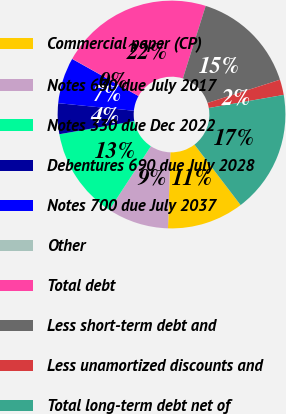<chart> <loc_0><loc_0><loc_500><loc_500><pie_chart><fcel>Commercial paper (CP)<fcel>Notes 630 due July 2017<fcel>Notes 330 due Dec 2022<fcel>Debentures 690 due July 2028<fcel>Notes 700 due July 2037<fcel>Other<fcel>Total debt<fcel>Less short-term debt and<fcel>Less unamortized discounts and<fcel>Total long-term debt net of<nl><fcel>10.87%<fcel>8.7%<fcel>13.04%<fcel>4.36%<fcel>6.53%<fcel>0.02%<fcel>21.71%<fcel>15.21%<fcel>2.19%<fcel>17.38%<nl></chart> 